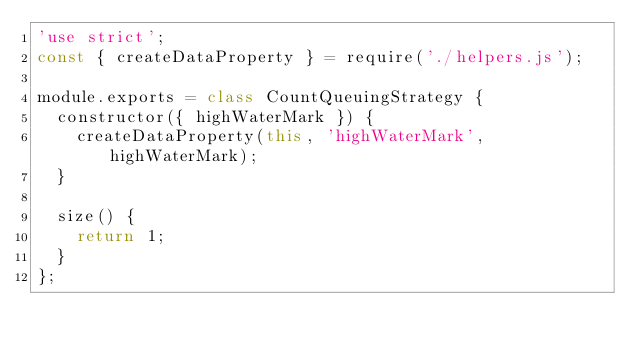Convert code to text. <code><loc_0><loc_0><loc_500><loc_500><_JavaScript_>'use strict';
const { createDataProperty } = require('./helpers.js');

module.exports = class CountQueuingStrategy {
  constructor({ highWaterMark }) {
    createDataProperty(this, 'highWaterMark', highWaterMark);
  }

  size() {
    return 1;
  }
};
</code> 